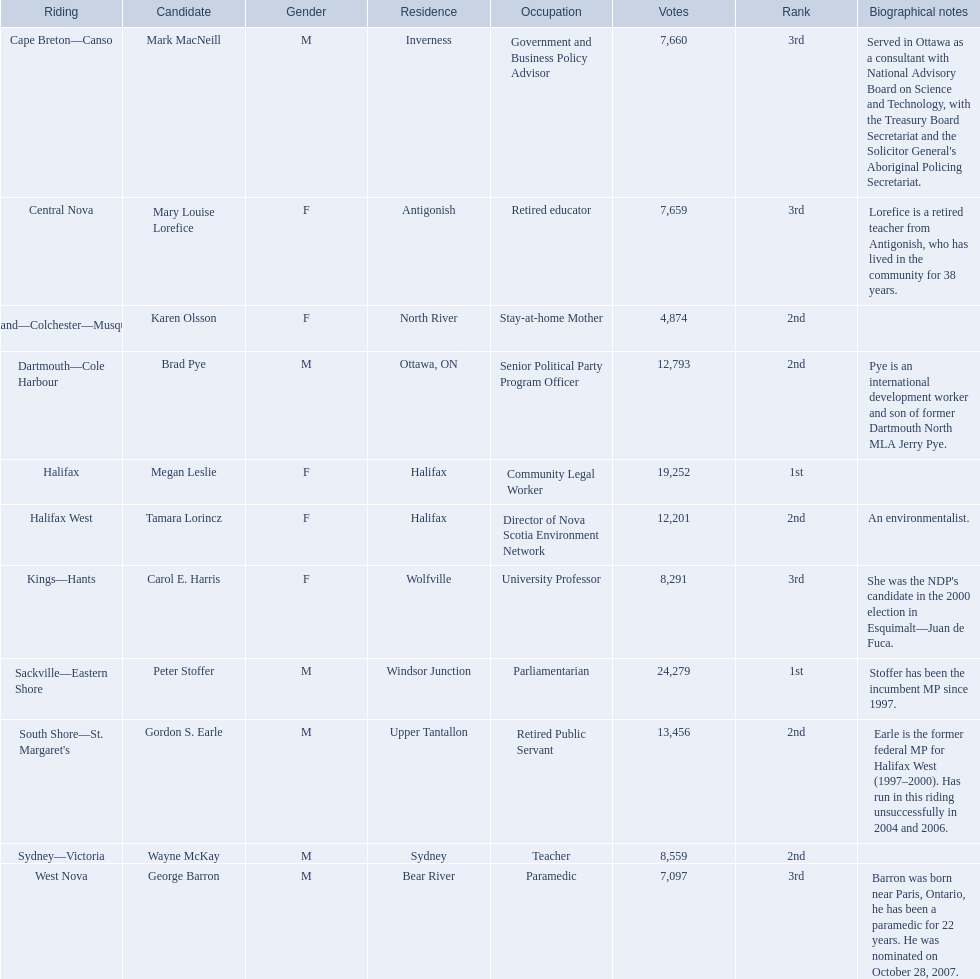Who were the new democratic party candidates, 2008? Mark MacNeill, Mary Louise Lorefice, Karen Olsson, Brad Pye, Megan Leslie, Tamara Lorincz, Carol E. Harris, Peter Stoffer, Gordon S. Earle, Wayne McKay, George Barron. Who had the 2nd highest number of votes? Megan Leslie, Peter Stoffer. How many votes did she receive? 19,252. 